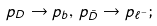<formula> <loc_0><loc_0><loc_500><loc_500>p _ { D } \to p _ { b } , \, p _ { \bar { D } } \to p _ { \ell ^ { - } } ;</formula> 